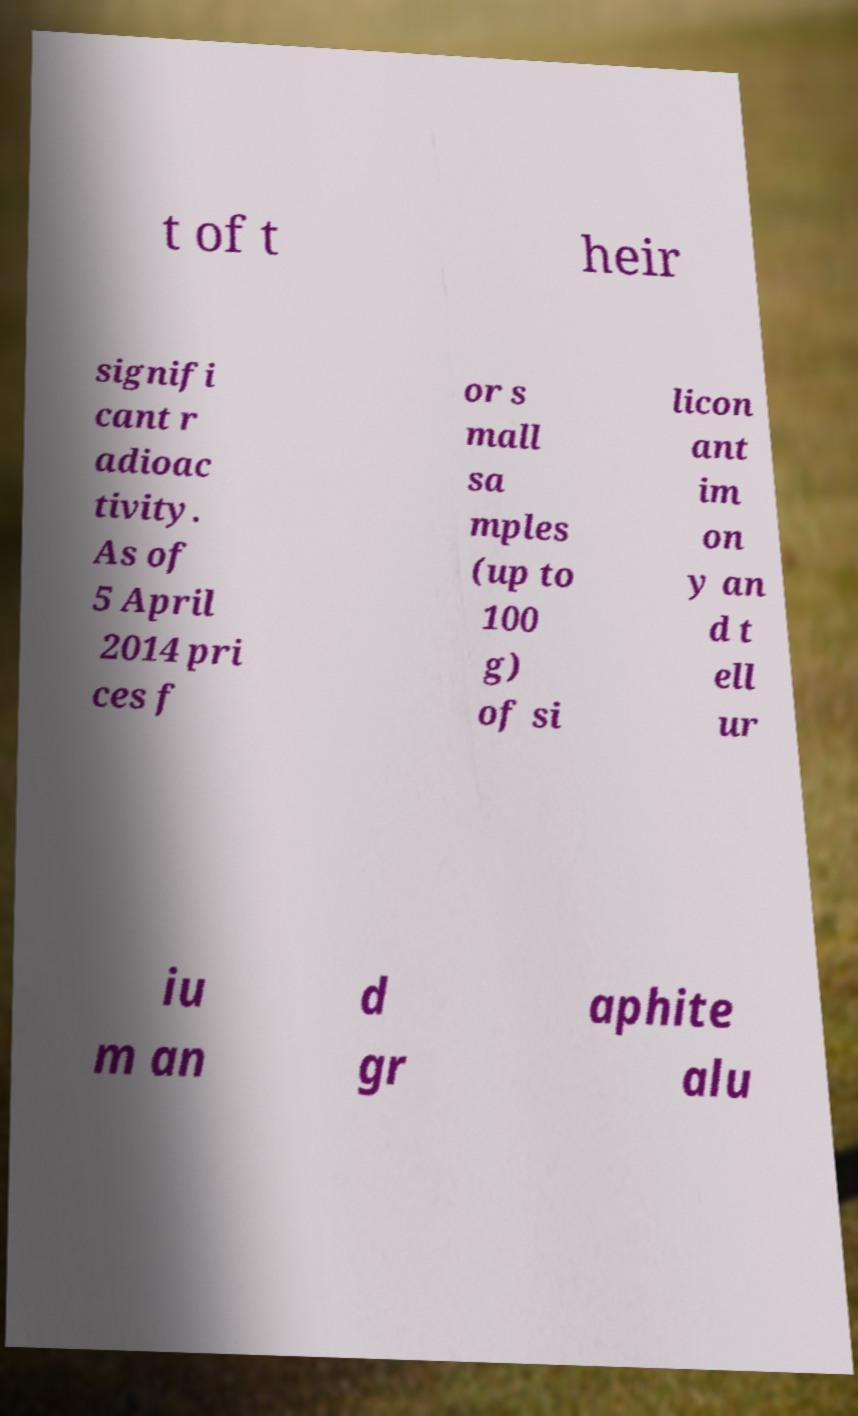What messages or text are displayed in this image? I need them in a readable, typed format. t of t heir signifi cant r adioac tivity. As of 5 April 2014 pri ces f or s mall sa mples (up to 100 g) of si licon ant im on y an d t ell ur iu m an d gr aphite alu 